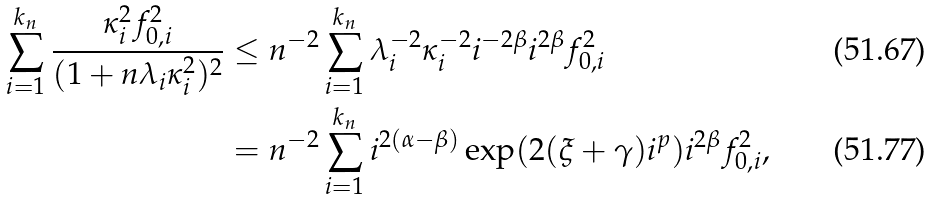<formula> <loc_0><loc_0><loc_500><loc_500>\sum _ { i = 1 } ^ { k _ { n } } \frac { \kappa _ { i } ^ { 2 } f _ { 0 , i } ^ { 2 } } { ( 1 + n \lambda _ { i } \kappa _ { i } ^ { 2 } ) ^ { 2 } } & \leq n ^ { - 2 } \sum _ { i = 1 } ^ { k _ { n } } \lambda _ { i } ^ { - 2 } \kappa _ { i } ^ { - 2 } i ^ { - 2 \beta } i ^ { 2 \beta } f _ { 0 , i } ^ { 2 } \\ & = n ^ { - 2 } \sum _ { i = 1 } ^ { k _ { n } } i ^ { 2 ( \alpha - \beta ) } \exp ( 2 ( \xi + \gamma ) i ^ { p } ) i ^ { 2 \beta } f _ { 0 , i } ^ { 2 } ,</formula> 